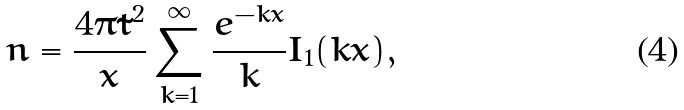Convert formula to latex. <formula><loc_0><loc_0><loc_500><loc_500>n = \frac { 4 \pi \tilde { t } ^ { 2 } } { x } \sum _ { k = 1 } ^ { \infty } \frac { e ^ { - k x } } { k } I _ { 1 } ( k x ) ,</formula> 